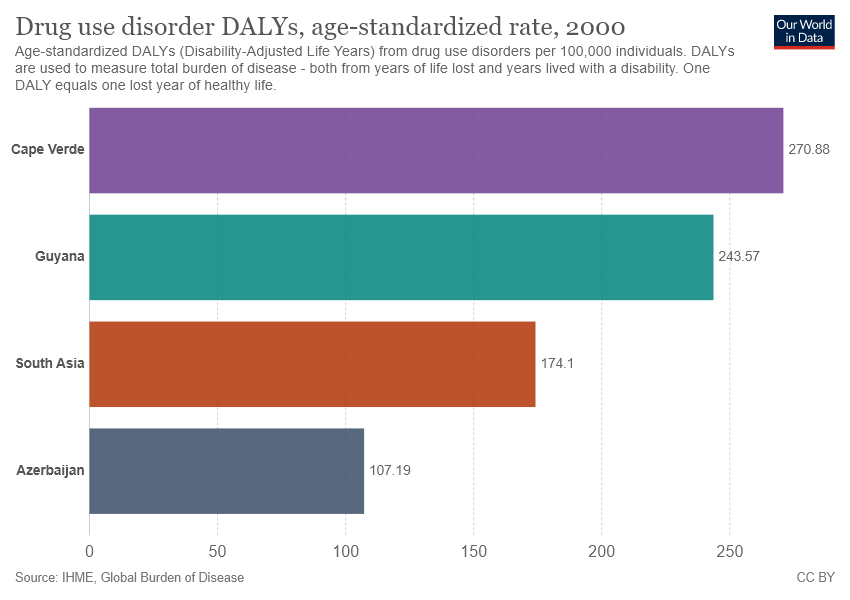Identify some key points in this picture. The sum of the smallest two bars is greater than the largest bar. The smallest bar has a value of 107.19. 